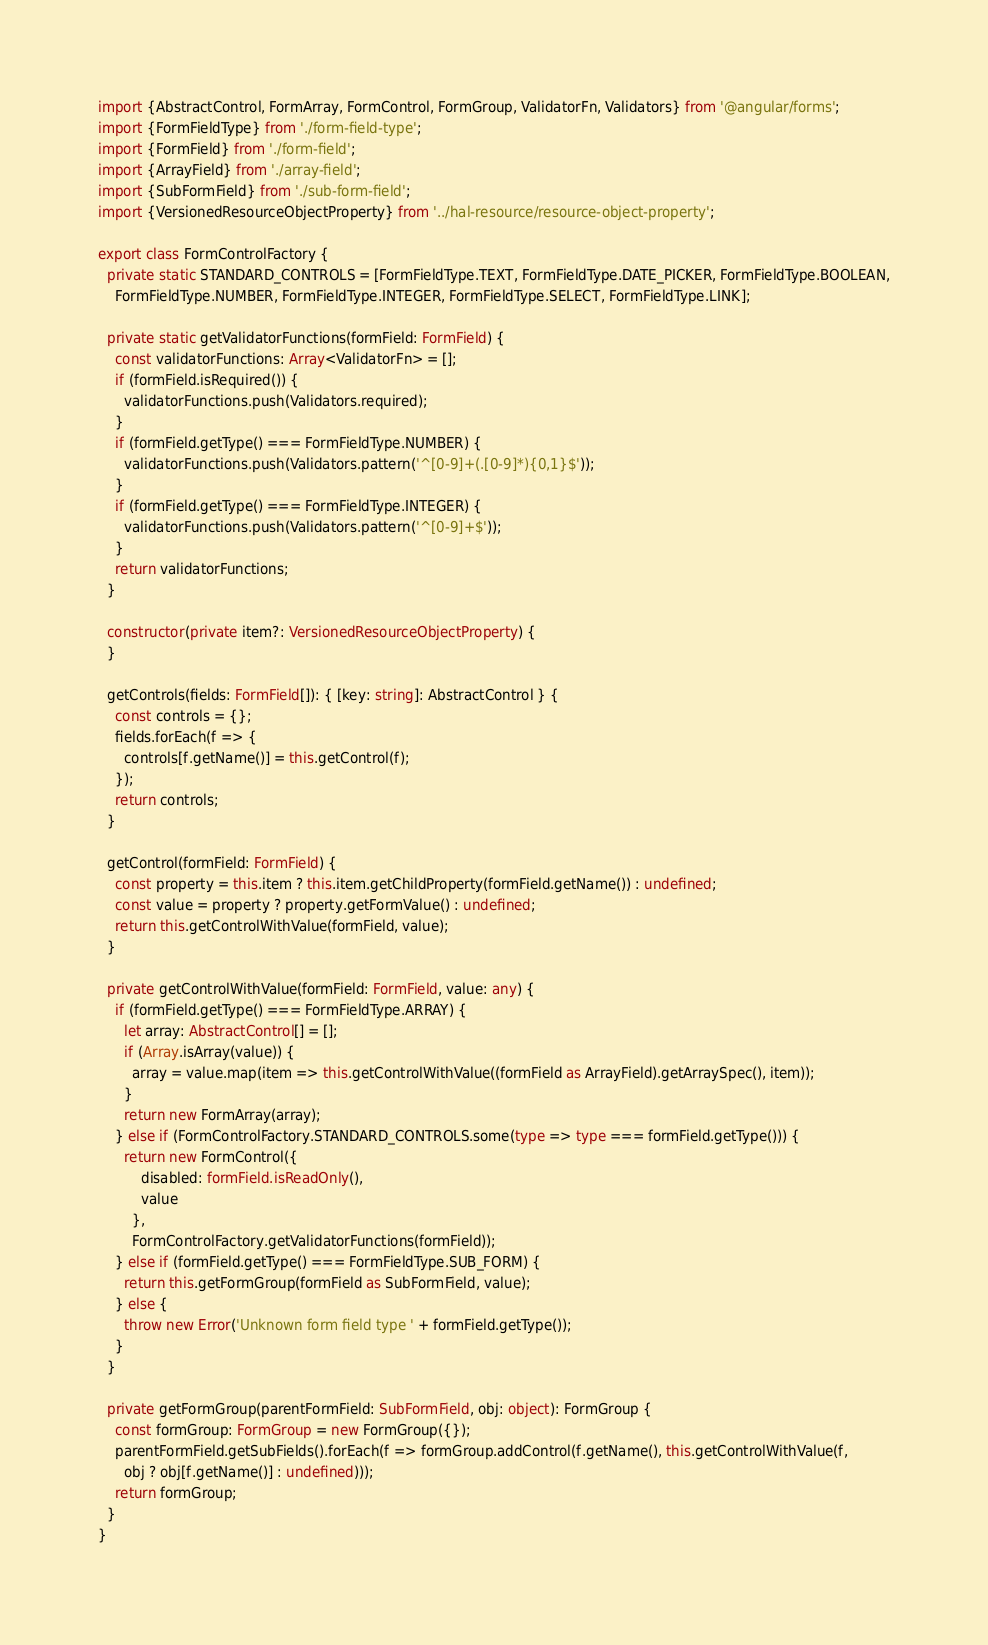Convert code to text. <code><loc_0><loc_0><loc_500><loc_500><_TypeScript_>import {AbstractControl, FormArray, FormControl, FormGroup, ValidatorFn, Validators} from '@angular/forms';
import {FormFieldType} from './form-field-type';
import {FormField} from './form-field';
import {ArrayField} from './array-field';
import {SubFormField} from './sub-form-field';
import {VersionedResourceObjectProperty} from '../hal-resource/resource-object-property';

export class FormControlFactory {
  private static STANDARD_CONTROLS = [FormFieldType.TEXT, FormFieldType.DATE_PICKER, FormFieldType.BOOLEAN,
    FormFieldType.NUMBER, FormFieldType.INTEGER, FormFieldType.SELECT, FormFieldType.LINK];

  private static getValidatorFunctions(formField: FormField) {
    const validatorFunctions: Array<ValidatorFn> = [];
    if (formField.isRequired()) {
      validatorFunctions.push(Validators.required);
    }
    if (formField.getType() === FormFieldType.NUMBER) {
      validatorFunctions.push(Validators.pattern('^[0-9]+(.[0-9]*){0,1}$'));
    }
    if (formField.getType() === FormFieldType.INTEGER) {
      validatorFunctions.push(Validators.pattern('^[0-9]+$'));
    }
    return validatorFunctions;
  }

  constructor(private item?: VersionedResourceObjectProperty) {
  }

  getControls(fields: FormField[]): { [key: string]: AbstractControl } {
    const controls = {};
    fields.forEach(f => {
      controls[f.getName()] = this.getControl(f);
    });
    return controls;
  }

  getControl(formField: FormField) {
    const property = this.item ? this.item.getChildProperty(formField.getName()) : undefined;
    const value = property ? property.getFormValue() : undefined;
    return this.getControlWithValue(formField, value);
  }

  private getControlWithValue(formField: FormField, value: any) {
    if (formField.getType() === FormFieldType.ARRAY) {
      let array: AbstractControl[] = [];
      if (Array.isArray(value)) {
        array = value.map(item => this.getControlWithValue((formField as ArrayField).getArraySpec(), item));
      }
      return new FormArray(array);
    } else if (FormControlFactory.STANDARD_CONTROLS.some(type => type === formField.getType())) {
      return new FormControl({
          disabled: formField.isReadOnly(),
          value
        },
        FormControlFactory.getValidatorFunctions(formField));
    } else if (formField.getType() === FormFieldType.SUB_FORM) {
      return this.getFormGroup(formField as SubFormField, value);
    } else {
      throw new Error('Unknown form field type ' + formField.getType());
    }
  }

  private getFormGroup(parentFormField: SubFormField, obj: object): FormGroup {
    const formGroup: FormGroup = new FormGroup({});
    parentFormField.getSubFields().forEach(f => formGroup.addControl(f.getName(), this.getControlWithValue(f,
      obj ? obj[f.getName()] : undefined)));
    return formGroup;
  }
}
</code> 